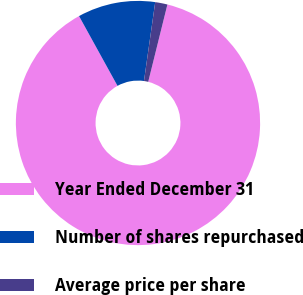Convert chart to OTSL. <chart><loc_0><loc_0><loc_500><loc_500><pie_chart><fcel>Year Ended December 31<fcel>Number of shares repurchased<fcel>Average price per share<nl><fcel>88.1%<fcel>10.27%<fcel>1.62%<nl></chart> 